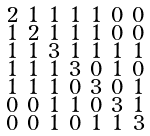Convert formula to latex. <formula><loc_0><loc_0><loc_500><loc_500>\begin{smallmatrix} 2 & 1 & 1 & 1 & 1 & 0 & 0 \\ 1 & 2 & 1 & 1 & 1 & 0 & 0 \\ 1 & 1 & 3 & 1 & 1 & 1 & 1 \\ 1 & 1 & 1 & 3 & 0 & 1 & 0 \\ 1 & 1 & 1 & 0 & 3 & 0 & 1 \\ 0 & 0 & 1 & 1 & 0 & 3 & 1 \\ 0 & 0 & 1 & 0 & 1 & 1 & 3 \end{smallmatrix}</formula> 